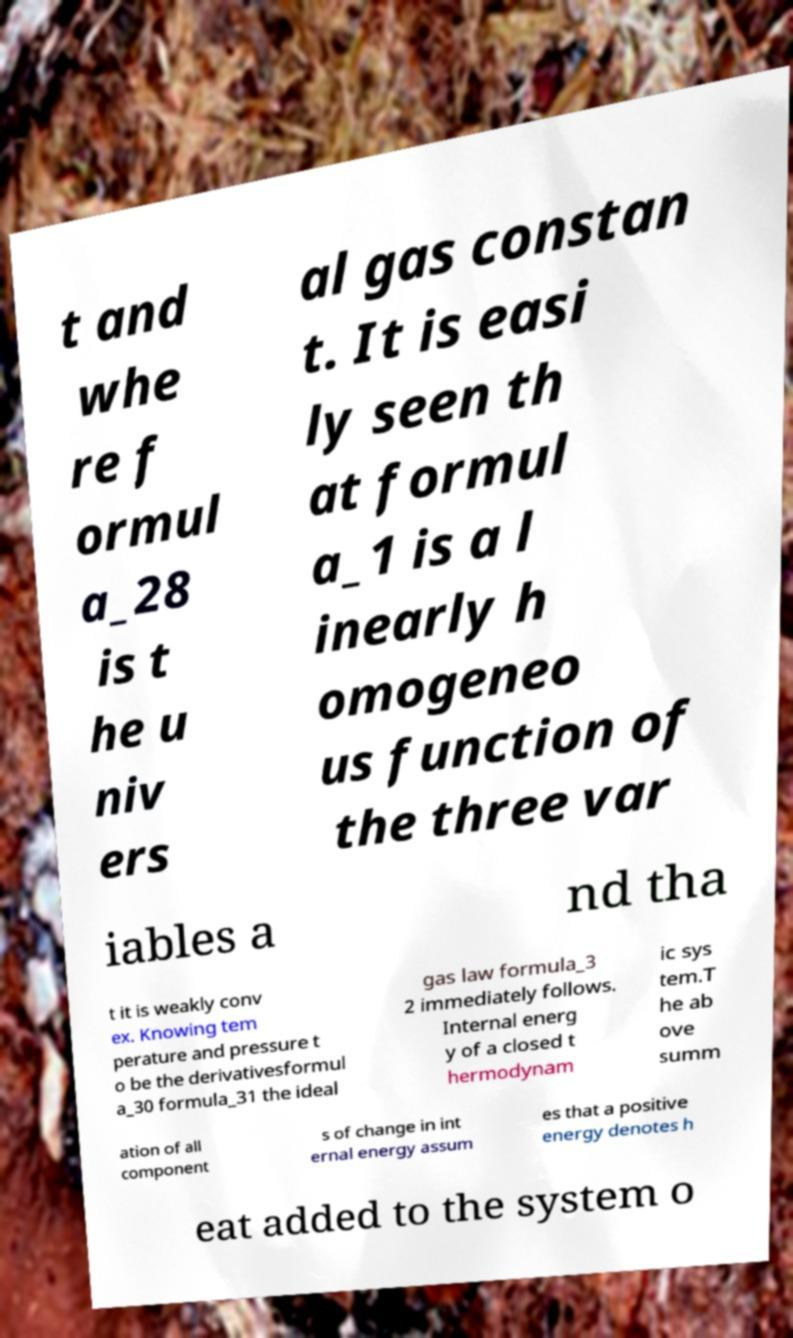Could you extract and type out the text from this image? t and whe re f ormul a_28 is t he u niv ers al gas constan t. It is easi ly seen th at formul a_1 is a l inearly h omogeneo us function of the three var iables a nd tha t it is weakly conv ex. Knowing tem perature and pressure t o be the derivativesformul a_30 formula_31 the ideal gas law formula_3 2 immediately follows. Internal energ y of a closed t hermodynam ic sys tem.T he ab ove summ ation of all component s of change in int ernal energy assum es that a positive energy denotes h eat added to the system o 